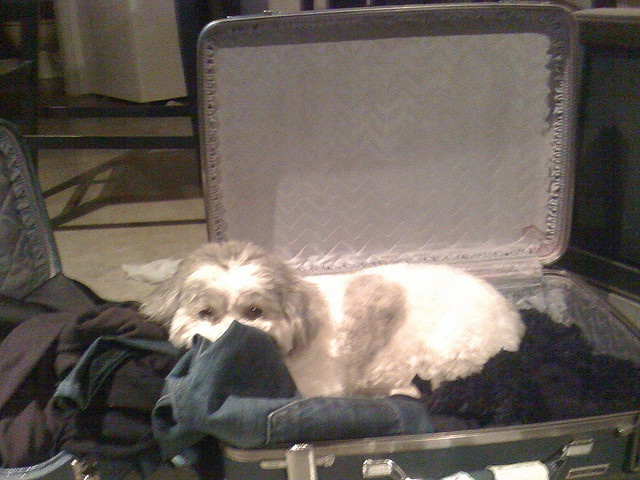Describe the objects in this image and their specific colors. I can see suitcase in black, gray, and darkgray tones and dog in black, ivory, and tan tones in this image. 